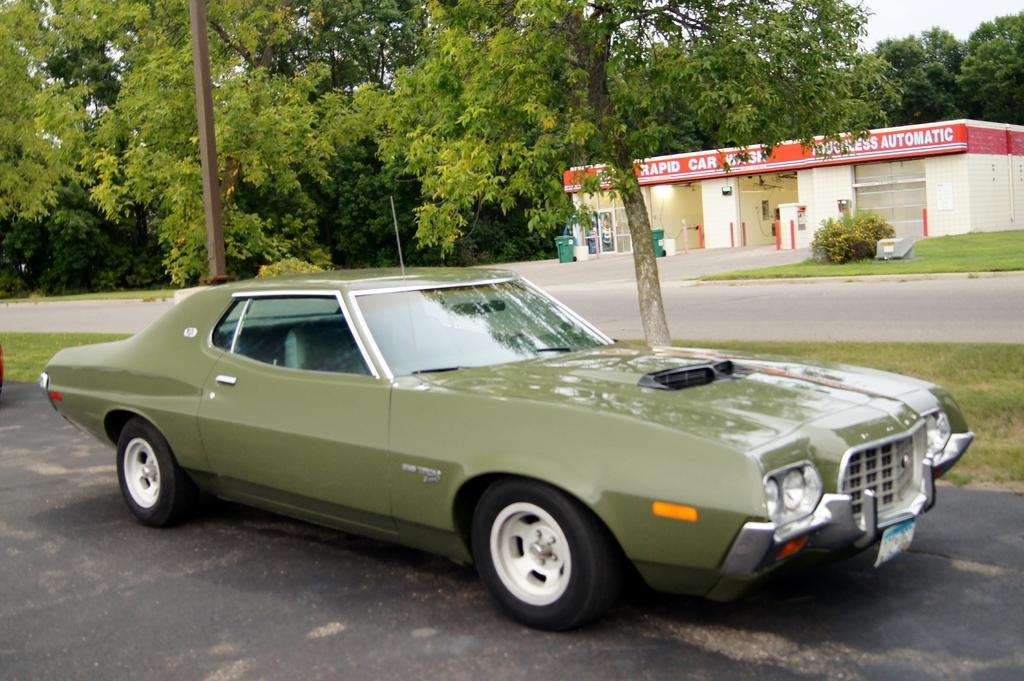What color is the car in the image? The car in the image is green. What type of structure can be seen in the image? There is a building in the image. What type of vegetation is visible in the image? There is grass, plants, and trees visible in the image. What can be used for waste disposal in the image? There are dustbins in the image. What part of the building can be seen in the image? There are windows in the image. What is visible at the top of the image? The sky is visible at the top of the image. What flavor of fly can be seen on the car in the image? There are no flies present in the image, and therefore no flavor can be determined. What type of basket is hanging from the tree in the image? There is no basket hanging from the tree in the image. 